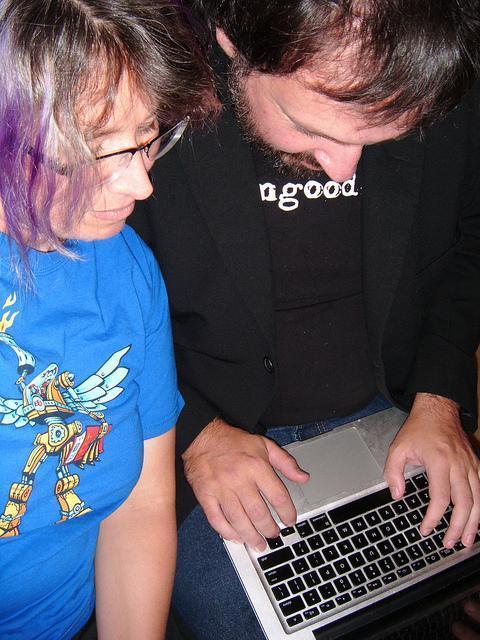How many people are in the picture?
Give a very brief answer. 2. 